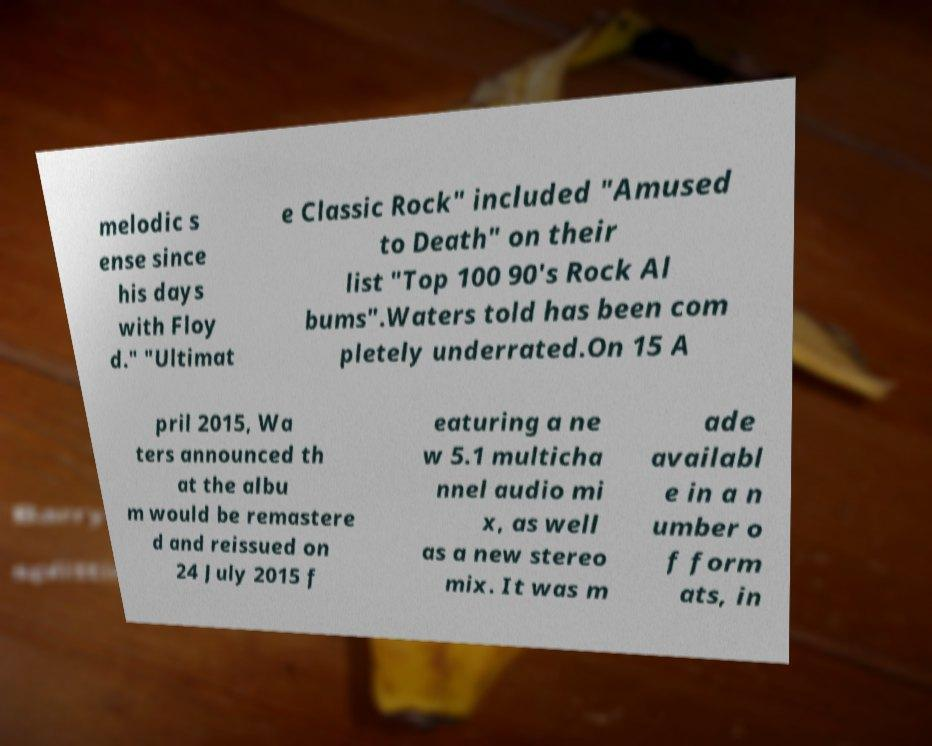I need the written content from this picture converted into text. Can you do that? melodic s ense since his days with Floy d." "Ultimat e Classic Rock" included "Amused to Death" on their list "Top 100 90's Rock Al bums".Waters told has been com pletely underrated.On 15 A pril 2015, Wa ters announced th at the albu m would be remastere d and reissued on 24 July 2015 f eaturing a ne w 5.1 multicha nnel audio mi x, as well as a new stereo mix. It was m ade availabl e in a n umber o f form ats, in 